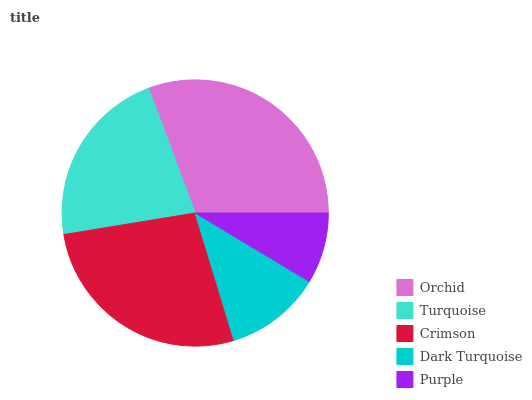Is Purple the minimum?
Answer yes or no. Yes. Is Orchid the maximum?
Answer yes or no. Yes. Is Turquoise the minimum?
Answer yes or no. No. Is Turquoise the maximum?
Answer yes or no. No. Is Orchid greater than Turquoise?
Answer yes or no. Yes. Is Turquoise less than Orchid?
Answer yes or no. Yes. Is Turquoise greater than Orchid?
Answer yes or no. No. Is Orchid less than Turquoise?
Answer yes or no. No. Is Turquoise the high median?
Answer yes or no. Yes. Is Turquoise the low median?
Answer yes or no. Yes. Is Orchid the high median?
Answer yes or no. No. Is Purple the low median?
Answer yes or no. No. 